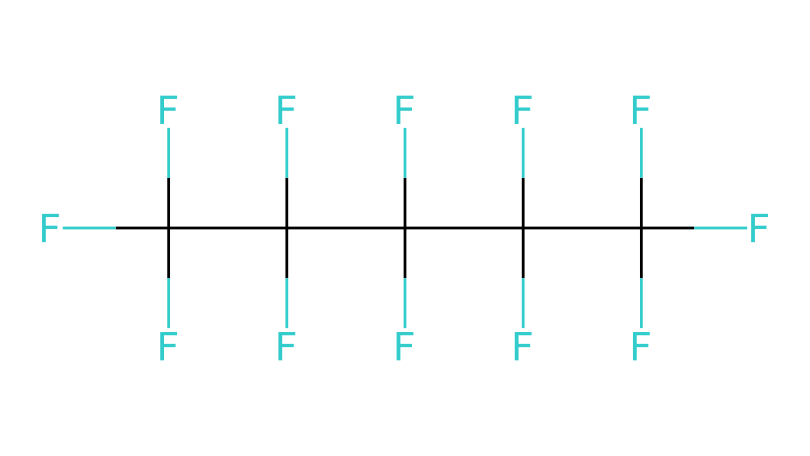What type of chemical compound is represented by this SMILES? The provided SMILES suggests a fluoropolymer compound due to the multiple fluorine (F) atoms attached to carbon (C) backbone. Fluoropolymers are known for their low friction and high chemical resistance properties, making them suitable for specialized applications.
Answer: fluoropolymer How many carbon atoms are present in this compound? By analyzing the SMILES representation, each 'C' indicates a carbon atom. Counting the 'C' symbols in the structure reveals there are six carbon atoms total.
Answer: six What is the predominant atom in this chemical structure? The visualization shows that fluorine (F) atoms are more numerous than carbon atoms throughout the structure, indicating that fluorine is the predominant atom in this chemical.
Answer: fluorine How many total fluorine atoms are in the compound? The SMILES structure contains several 'F' notations, and counting them results in a total of 13 fluorine atoms attached to the carbon backbone.
Answer: thirteen What structural feature of this compound contributes to its low-friction property? The extensive presence of fluorine atoms results in a strong carbon-fluorine bond, which creates a non-stick surface that is characteristic of fluoropolymer materials, contributing to their low-friction properties.
Answer: carbon-fluorine bond Is this compound likely to be hydrophilic or hydrophobic? Due to the dominance of fluorine and the lack of polar functional groups, this compound exhibits hydrophobic characteristics, meaning it repels water rather than attracting it.
Answer: hydrophobic Which category of compounds does this structure belong to based on its unique arrangements? The structure represents a type of cage compound, specifically a cage fluoropolymer, known for encapsulating gas or liquid in its form, which is relevant to specialized applications like sledge hockey coatings.
Answer: cage compound 